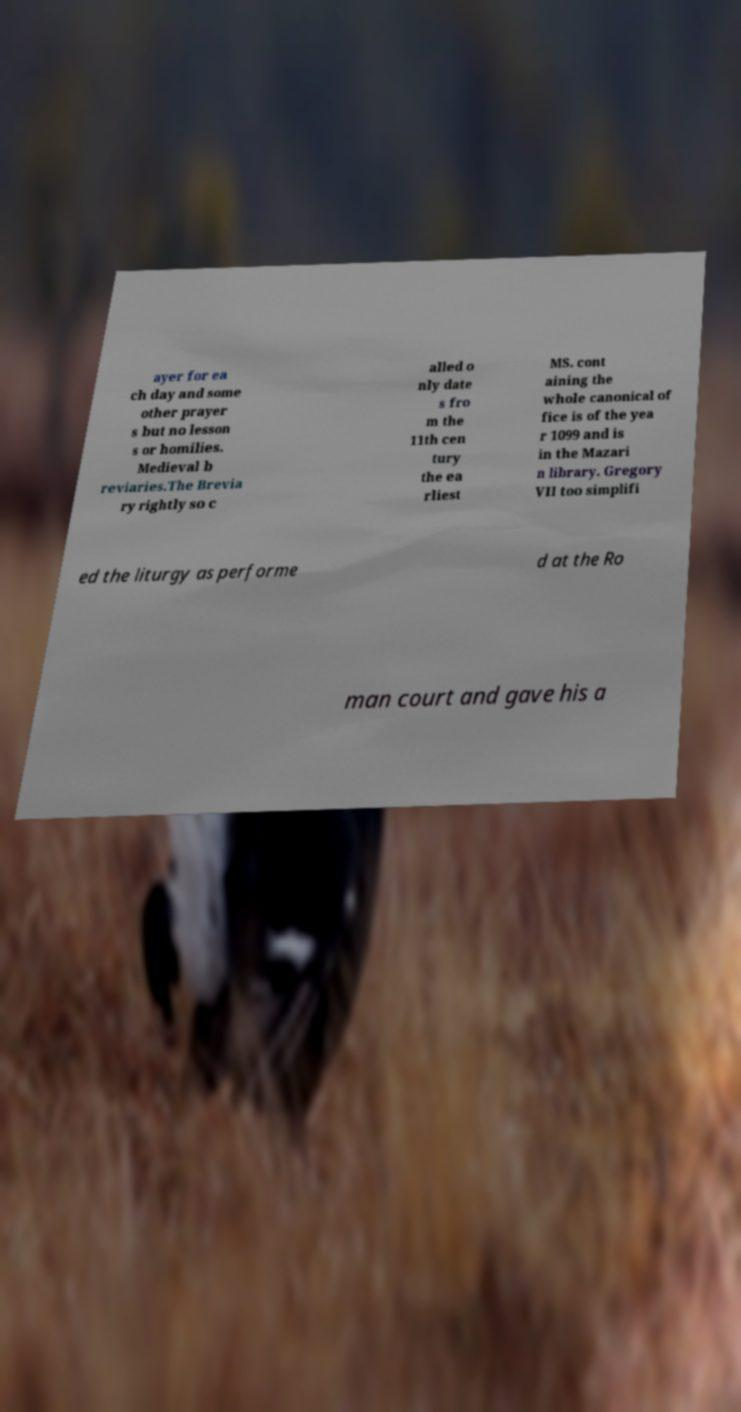There's text embedded in this image that I need extracted. Can you transcribe it verbatim? ayer for ea ch day and some other prayer s but no lesson s or homilies. Medieval b reviaries.The Brevia ry rightly so c alled o nly date s fro m the 11th cen tury the ea rliest MS. cont aining the whole canonical of fice is of the yea r 1099 and is in the Mazari n library. Gregory VII too simplifi ed the liturgy as performe d at the Ro man court and gave his a 